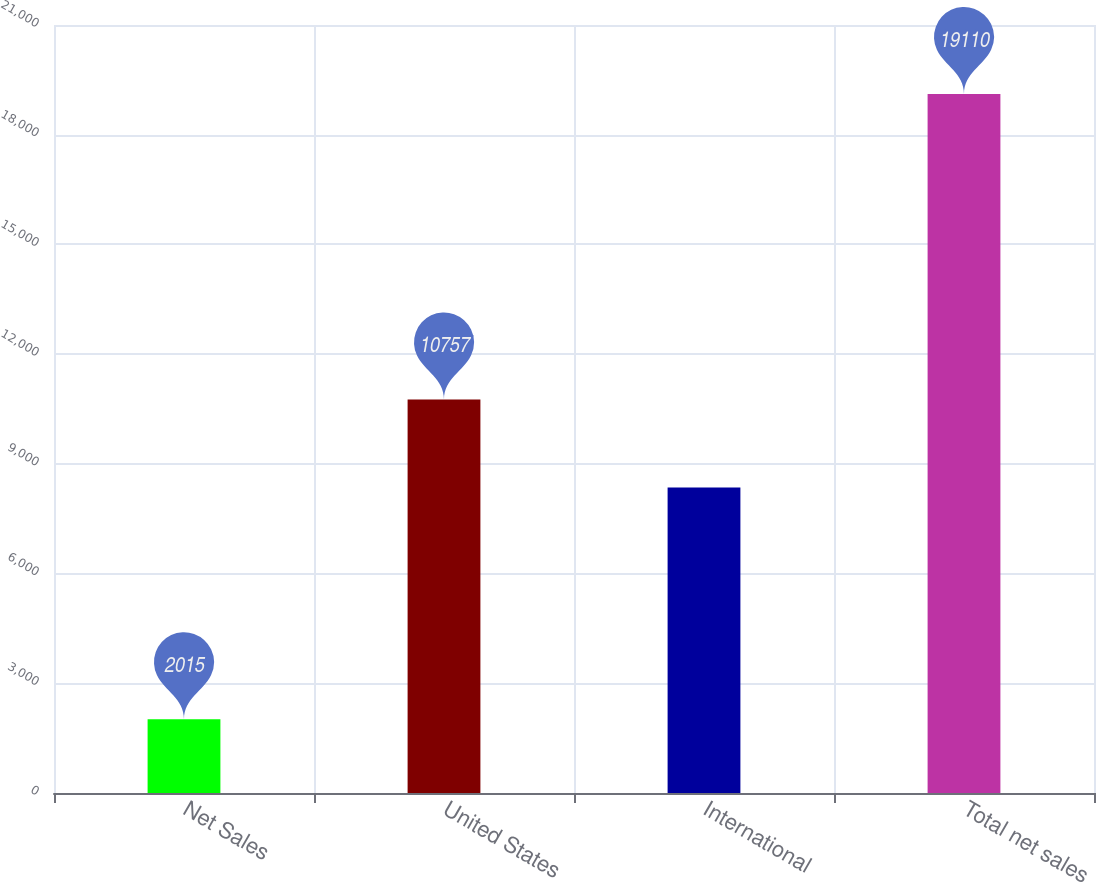Convert chart. <chart><loc_0><loc_0><loc_500><loc_500><bar_chart><fcel>Net Sales<fcel>United States<fcel>International<fcel>Total net sales<nl><fcel>2015<fcel>10757<fcel>8353<fcel>19110<nl></chart> 